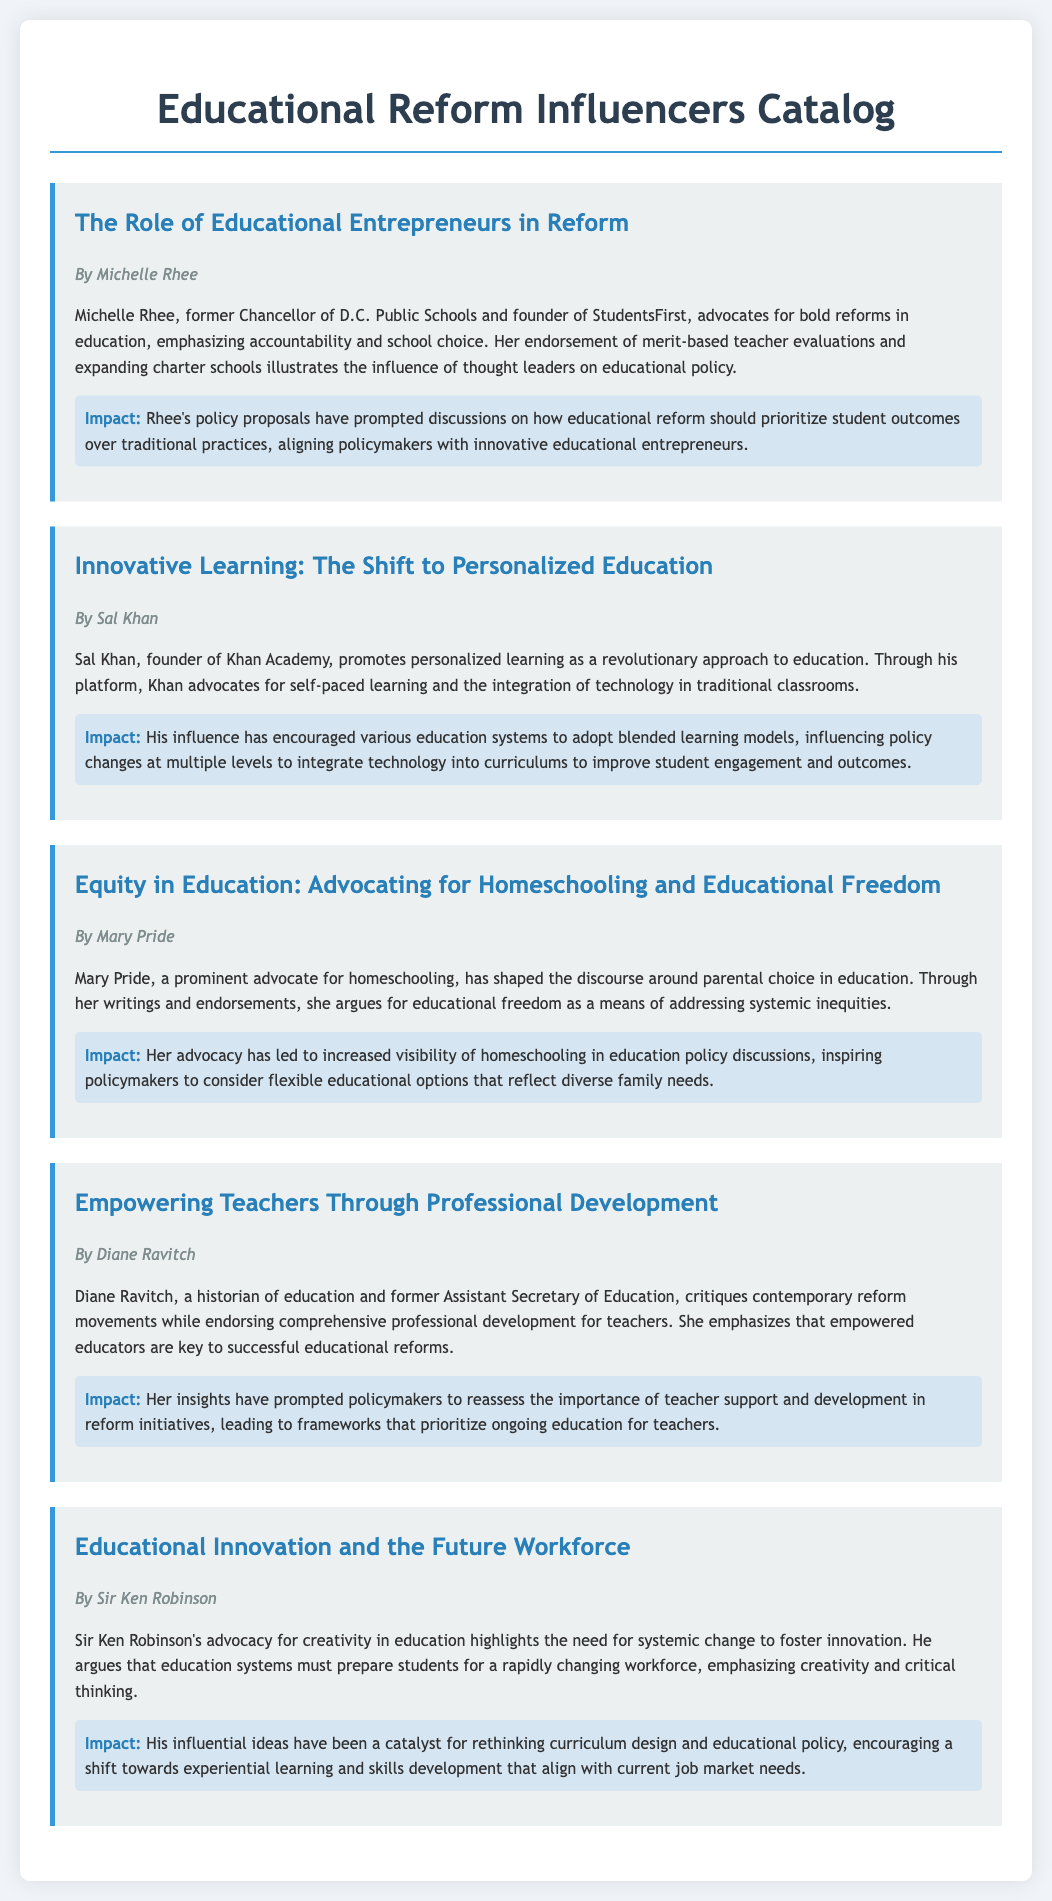what is the title of the first entry? The title of the first entry is located at the beginning of the section, which is "The Role of Educational Entrepreneurs in Reform."
Answer: The Role of Educational Entrepreneurs in Reform who is the author of the second entry? The author of the second entry is indicated below the title, which notes "By Sal Khan."
Answer: Sal Khan what educational approach does Sal Khan promote? The educational approach promoted by Sal Khan is described in his summary, specifically stated as "personalized learning."
Answer: personalized learning what is the main focus of Mary Pride's advocacy? The main focus of Mary Pride's advocacy is mentioned in her summary, highlighting "homeschooling and educational freedom."
Answer: homeschooling and educational freedom which thought leader emphasizes the importance of teacher development? The thought leader emphasizing teacher development is highlighted in her summarized section, which identifies her as "Diane Ravitch."
Answer: Diane Ravitch how many entries are listed in the catalog? The total number of entries can be counted from the document, which are five separate entries given.
Answer: five what type of education system change does Sir Ken Robinson advocate for? Sir Ken Robinson's advocacy is detailed in his summary, where he mentions the need for "systemic change."
Answer: systemic change which influential figure is associated with StudentsFirst? The influential figure associated with StudentsFirst is stated directly in the document, being "Michelle Rhee."
Answer: Michelle Rhee 